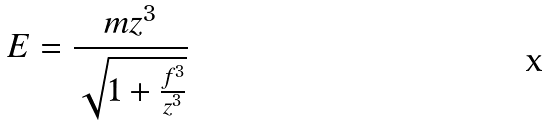<formula> <loc_0><loc_0><loc_500><loc_500>E = \frac { m z ^ { 3 } } { \sqrt { 1 + \frac { f ^ { 3 } } { z ^ { 3 } } } }</formula> 